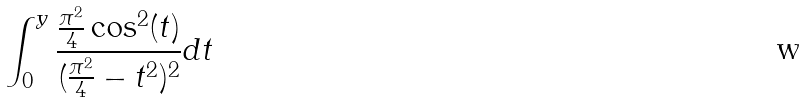<formula> <loc_0><loc_0><loc_500><loc_500>\int _ { 0 } ^ { y } \frac { \frac { \pi ^ { 2 } } { 4 } \cos ^ { 2 } ( t ) } { ( \frac { \pi ^ { 2 } } { 4 } - t ^ { 2 } ) ^ { 2 } } d t</formula> 